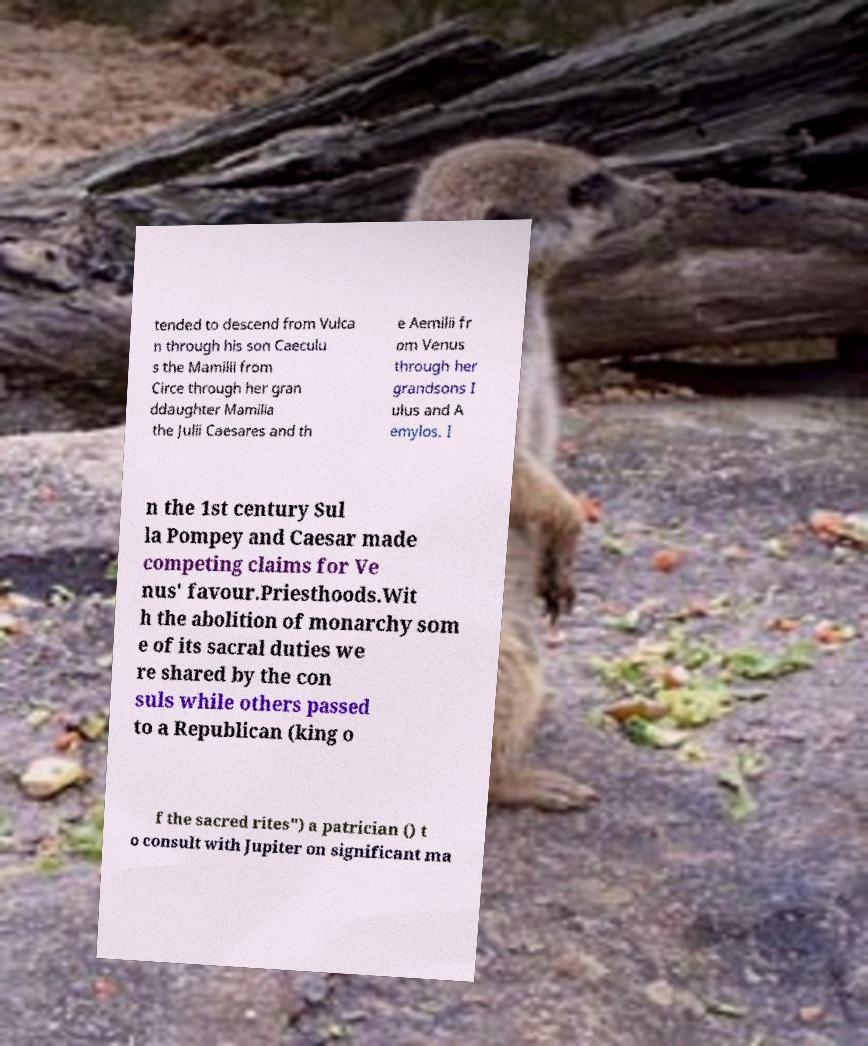Can you accurately transcribe the text from the provided image for me? tended to descend from Vulca n through his son Caeculu s the Mamilii from Circe through her gran ddaughter Mamilia the Julii Caesares and th e Aemilii fr om Venus through her grandsons I ulus and A emylos. I n the 1st century Sul la Pompey and Caesar made competing claims for Ve nus' favour.Priesthoods.Wit h the abolition of monarchy som e of its sacral duties we re shared by the con suls while others passed to a Republican (king o f the sacred rites") a patrician () t o consult with Jupiter on significant ma 